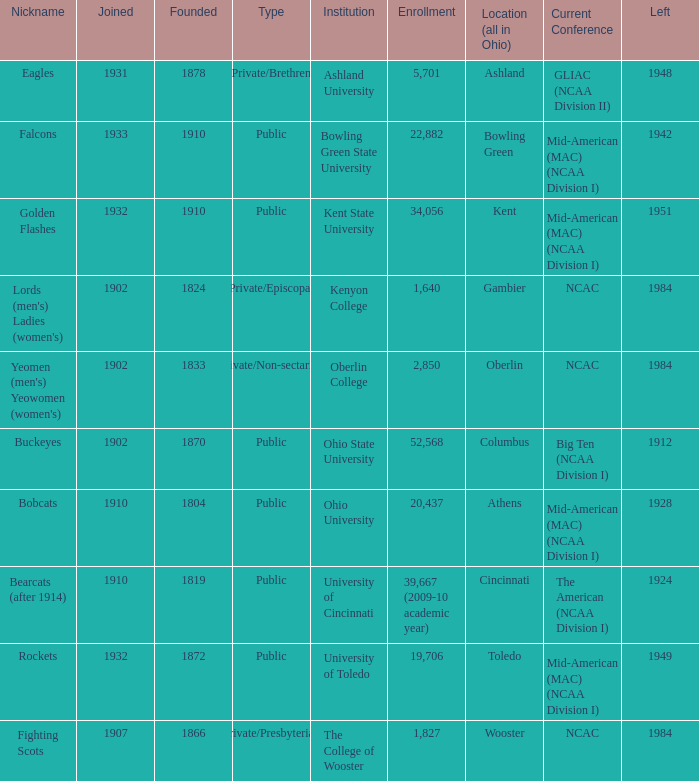Which year did enrolled Gambier members leave? 1984.0. 